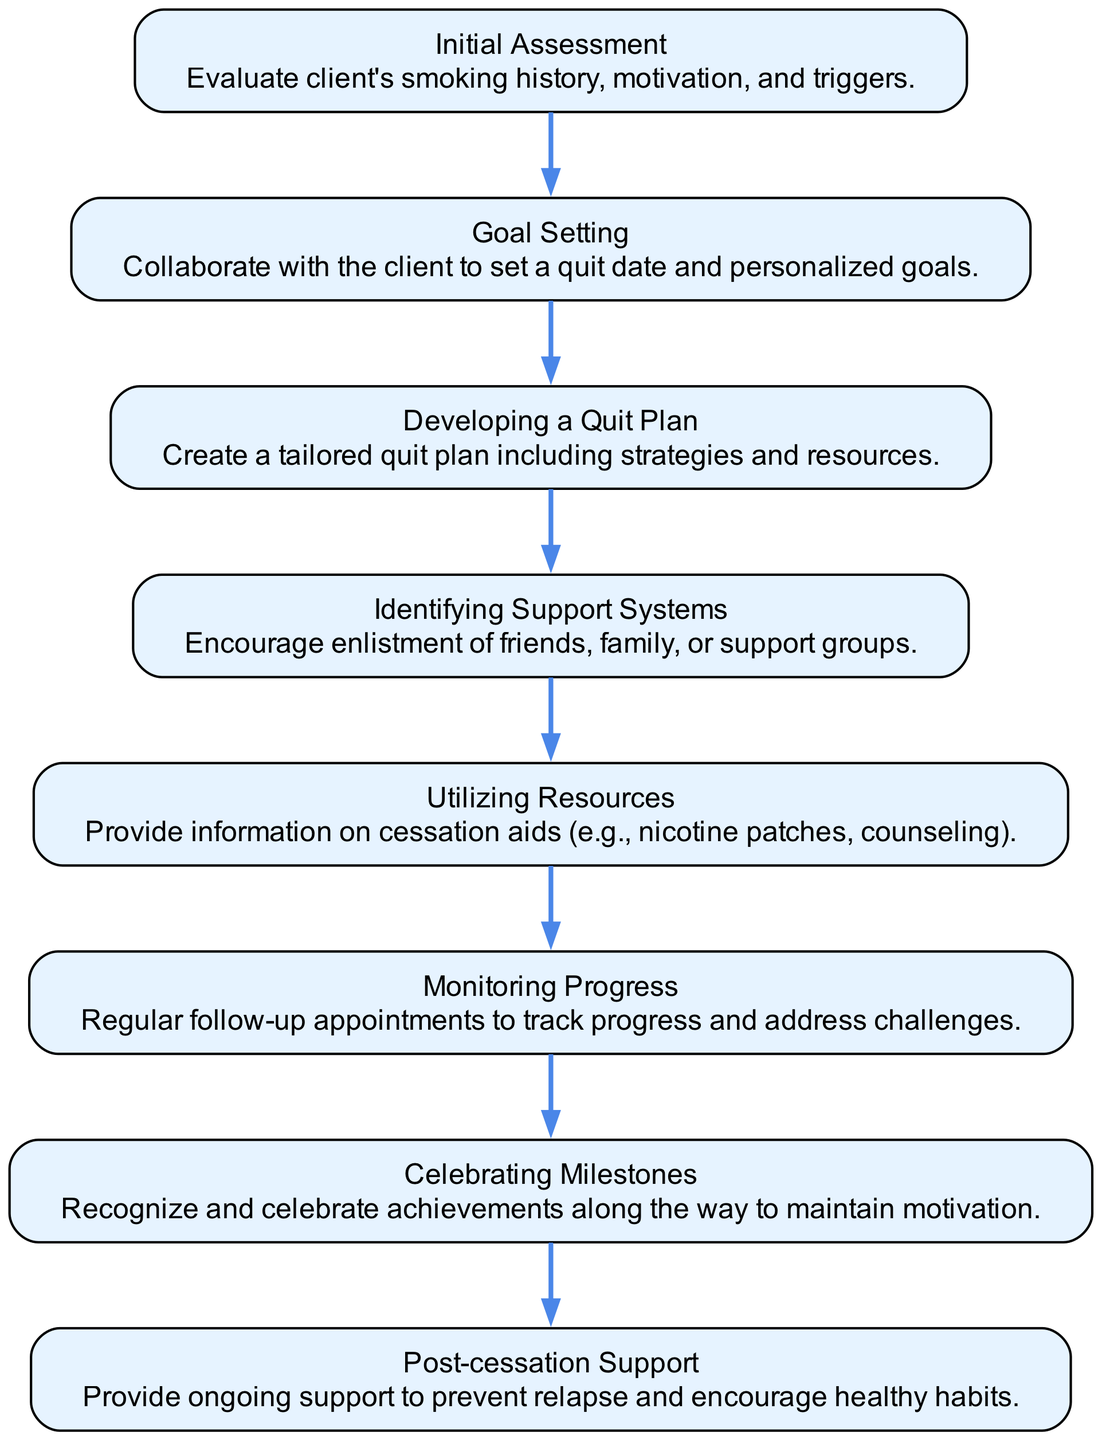What is the first process step in the flow chart? The flow chart starts with the "Initial Assessment" process step. This can be identified as the first element listed in the sequence of steps.
Answer: Initial Assessment How many total process steps are there? By counting the number of elements in the flow chart, we find there are 8 distinct process steps listed sequentially.
Answer: 8 What is the last process step in the flow chart? The final step in the flow chart is "Post-cessation Support," which is indicated as the last element in the series of process steps.
Answer: Post-cessation Support Which process step involves setting a quit date? The "Goal Setting" process step specifically includes collaborating with the client to set a quit date, as mentioned in its description.
Answer: Goal Setting What is the main purpose of the "Monitoring Progress" step? The "Monitoring Progress" step is intended for regular follow-up appointments to track the client's progress and address any challenges they may face during the cessation process.
Answer: Regular follow-up appointments What do the "Developing a Quit Plan" and "Utilizing Resources" steps have in common? Both steps focus on preparing the client with necessary tools and strategies for quitting smoking, and they are sequential steps in the flow chart. "Developing a Quit Plan" creates a tailored approach, while "Utilizing Resources" provides actual aids and support for cessation.
Answer: Preparing tools and strategies Which step directly follows the "Identifying Support Systems" step? The step that directly follows "Identifying Support Systems" is "Utilizing Resources." This can be determined by following the directional flow from one step to the next in the diagram.
Answer: Utilizing Resources What is the purpose of "Celebrating Milestones"? The "Celebrating Milestones" step emphasizes recognizing and celebrating achievements throughout the cessation journey to maintain motivation for the client.
Answer: Maintain motivation 